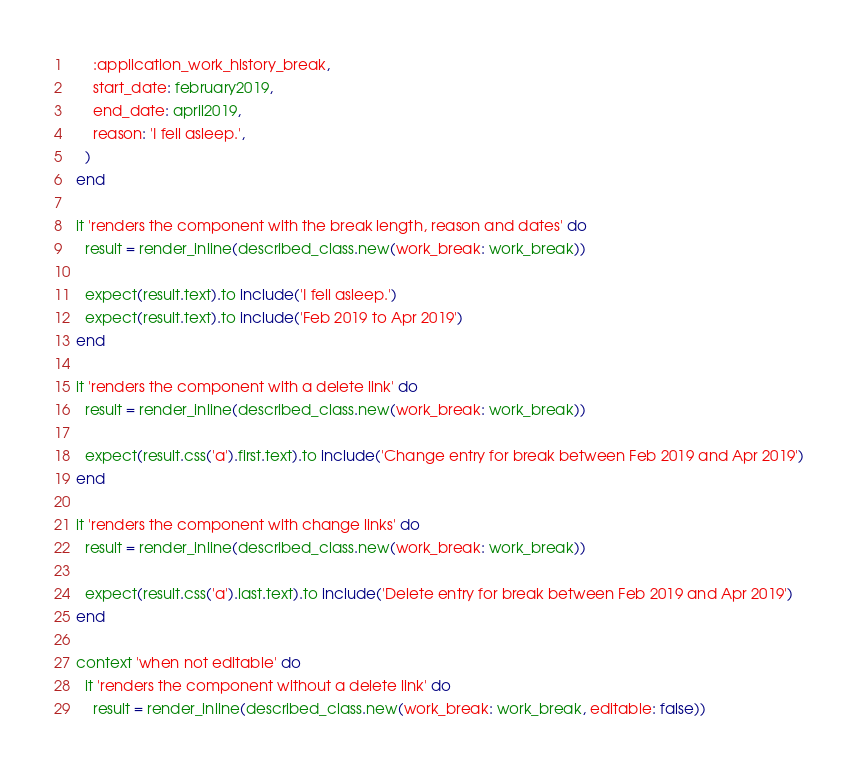<code> <loc_0><loc_0><loc_500><loc_500><_Ruby_>      :application_work_history_break,
      start_date: february2019,
      end_date: april2019,
      reason: 'I fell asleep.',
    )
  end

  it 'renders the component with the break length, reason and dates' do
    result = render_inline(described_class.new(work_break: work_break))

    expect(result.text).to include('I fell asleep.')
    expect(result.text).to include('Feb 2019 to Apr 2019')
  end

  it 'renders the component with a delete link' do
    result = render_inline(described_class.new(work_break: work_break))

    expect(result.css('a').first.text).to include('Change entry for break between Feb 2019 and Apr 2019')
  end

  it 'renders the component with change links' do
    result = render_inline(described_class.new(work_break: work_break))

    expect(result.css('a').last.text).to include('Delete entry for break between Feb 2019 and Apr 2019')
  end

  context 'when not editable' do
    it 'renders the component without a delete link' do
      result = render_inline(described_class.new(work_break: work_break, editable: false))
</code> 